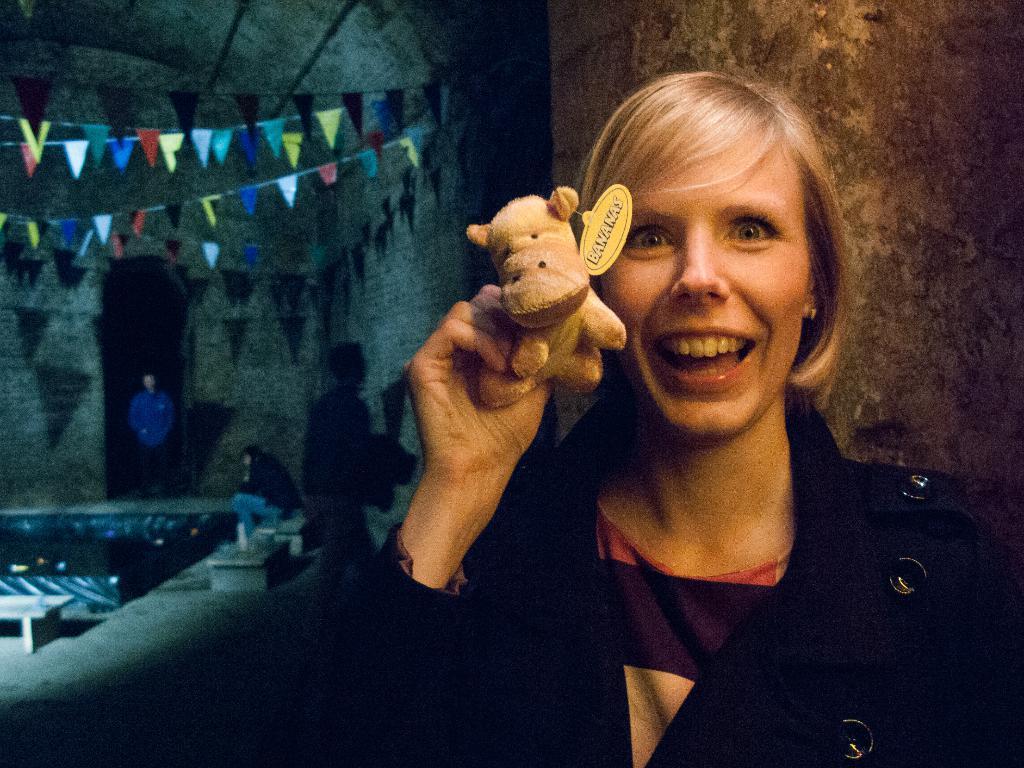Describe this image in one or two sentences. This picture describe about the women wearing black coat holding a small teddy bear in the hand and giving a pose in the camera. Behind we can see colorful decorative flags. In the front center we can see a man standing and looking in the camera. 